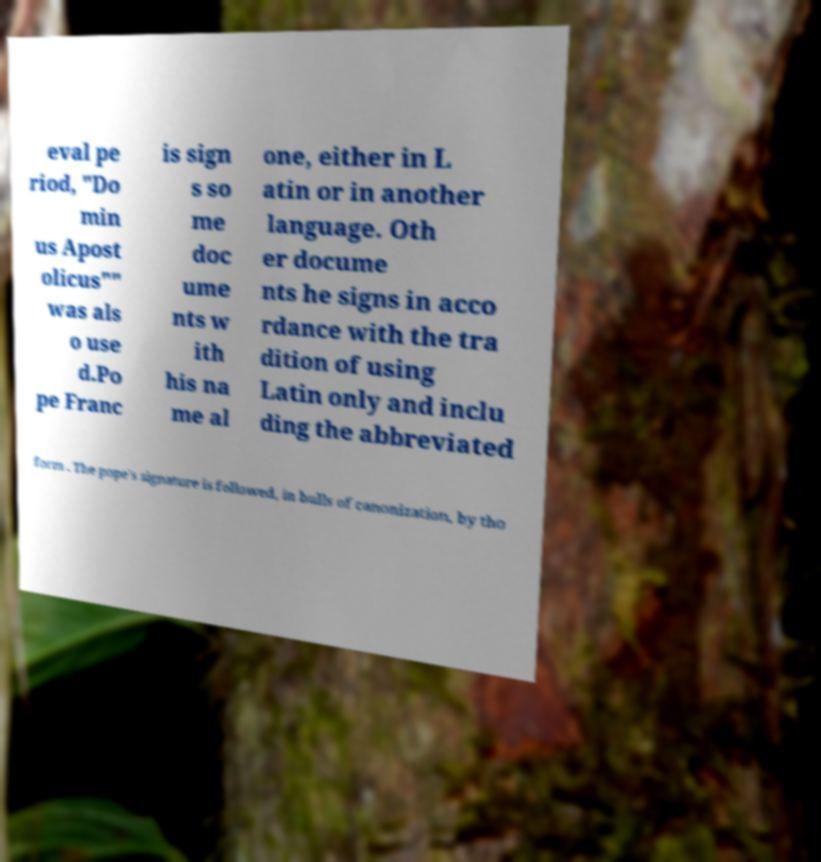Can you read and provide the text displayed in the image?This photo seems to have some interesting text. Can you extract and type it out for me? eval pe riod, "Do min us Apost olicus"" was als o use d.Po pe Franc is sign s so me doc ume nts w ith his na me al one, either in L atin or in another language. Oth er docume nts he signs in acco rdance with the tra dition of using Latin only and inclu ding the abbreviated form . The pope's signature is followed, in bulls of canonization, by tho 